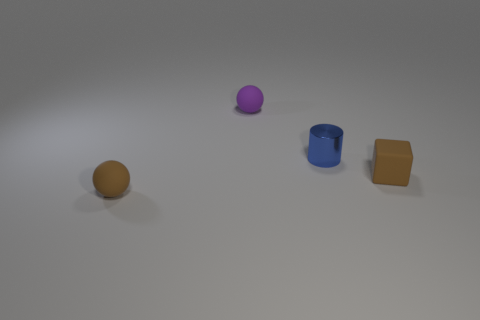Add 3 tiny shiny cylinders. How many objects exist? 7 Add 3 small blue cylinders. How many small blue cylinders exist? 4 Subtract 0 red cubes. How many objects are left? 4 Subtract all blocks. How many objects are left? 3 Subtract all big metallic blocks. Subtract all small purple things. How many objects are left? 3 Add 1 tiny brown matte blocks. How many tiny brown matte blocks are left? 2 